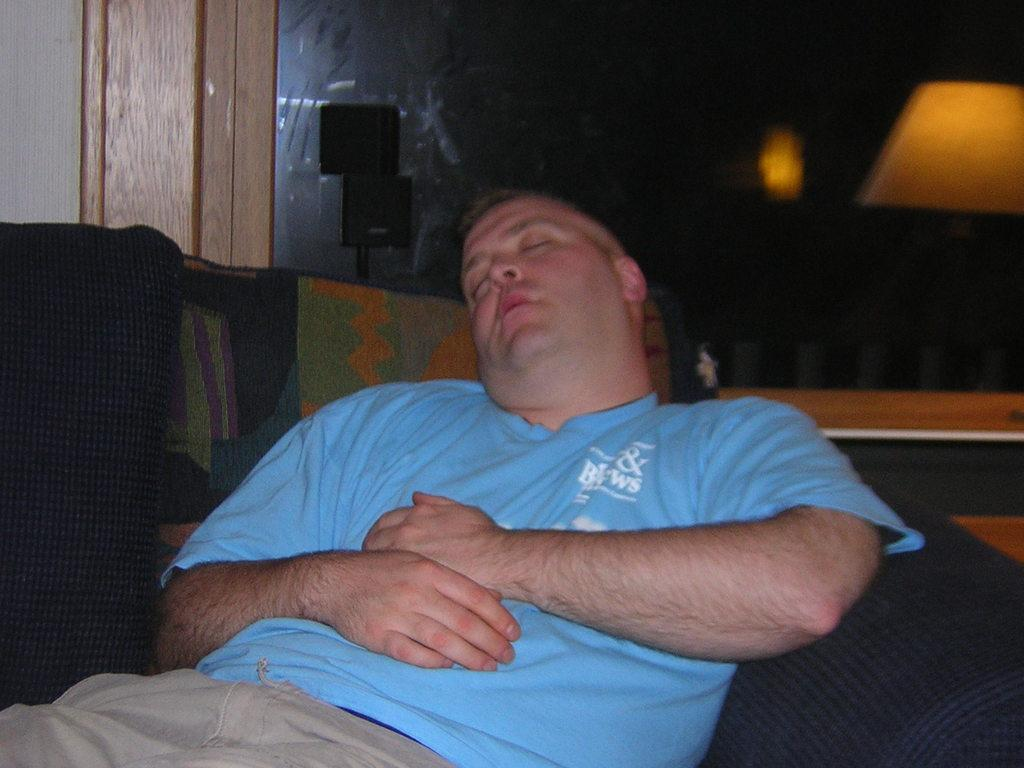What is happening in the image? There is a person in the image, and they are sleeping. What is the person wearing in the image? The person is wearing a blue T-shirt. What can be observed about the lighting in the image? The background of the image is dark. What is the person writing on the side in the image? There is no writing or side visible in the image; the person is simply sleeping while wearing a blue T-shirt. 